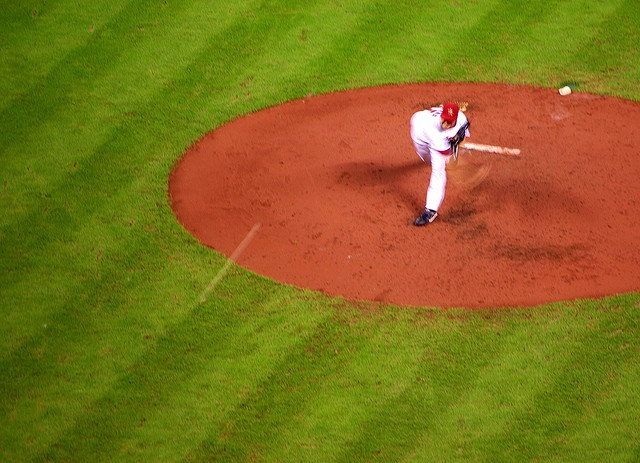Describe the objects in this image and their specific colors. I can see people in darkgreen, lavender, violet, black, and brown tones, baseball bat in darkgreen, salmon, and white tones, and sports ball in darkgreen, beige, and tan tones in this image. 